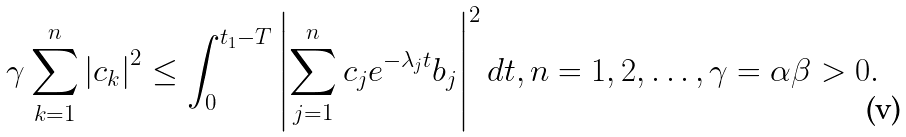<formula> <loc_0><loc_0><loc_500><loc_500>\gamma \sum _ { k = 1 } ^ { n } \left | c _ { k } \right | ^ { 2 } \leq \int _ { 0 } ^ { t _ { 1 } - T } \left | \sum _ { j = 1 } ^ { n } c _ { j } e ^ { - \lambda _ { j } t } b _ { j } \right | ^ { 2 } d t , n = 1 , 2 , \dots , \gamma = \alpha \beta > 0 .</formula> 